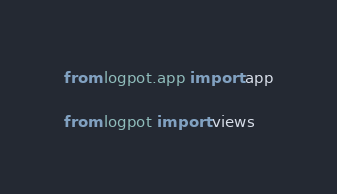<code> <loc_0><loc_0><loc_500><loc_500><_Python_>
from logpot.app import app

from logpot import views
</code> 